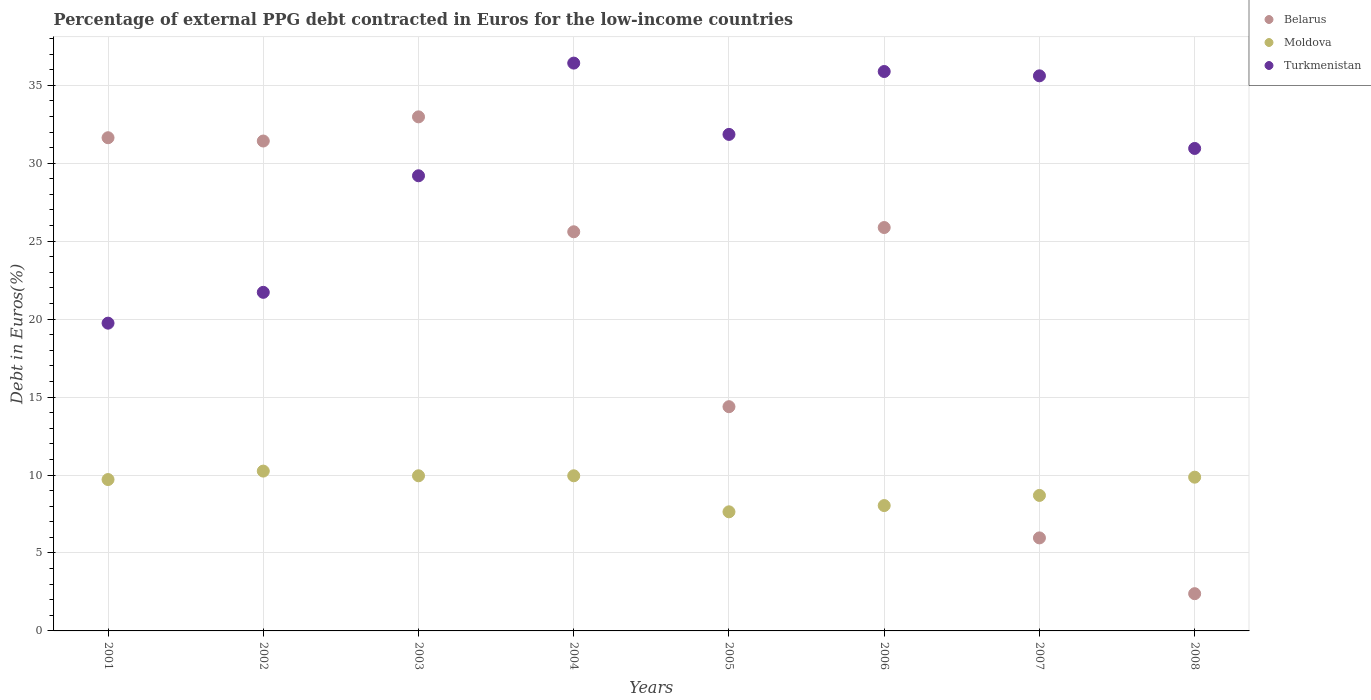Is the number of dotlines equal to the number of legend labels?
Provide a succinct answer. Yes. What is the percentage of external PPG debt contracted in Euros in Turkmenistan in 2007?
Make the answer very short. 35.6. Across all years, what is the maximum percentage of external PPG debt contracted in Euros in Moldova?
Offer a terse response. 10.25. Across all years, what is the minimum percentage of external PPG debt contracted in Euros in Belarus?
Keep it short and to the point. 2.39. In which year was the percentage of external PPG debt contracted in Euros in Turkmenistan minimum?
Keep it short and to the point. 2001. What is the total percentage of external PPG debt contracted in Euros in Moldova in the graph?
Your answer should be very brief. 74.09. What is the difference between the percentage of external PPG debt contracted in Euros in Belarus in 2006 and that in 2008?
Offer a very short reply. 23.48. What is the difference between the percentage of external PPG debt contracted in Euros in Moldova in 2006 and the percentage of external PPG debt contracted in Euros in Turkmenistan in 2003?
Your response must be concise. -21.15. What is the average percentage of external PPG debt contracted in Euros in Belarus per year?
Offer a very short reply. 21.28. In the year 2005, what is the difference between the percentage of external PPG debt contracted in Euros in Turkmenistan and percentage of external PPG debt contracted in Euros in Moldova?
Give a very brief answer. 24.21. In how many years, is the percentage of external PPG debt contracted in Euros in Moldova greater than 2 %?
Ensure brevity in your answer.  8. What is the ratio of the percentage of external PPG debt contracted in Euros in Moldova in 2003 to that in 2005?
Ensure brevity in your answer.  1.3. Is the difference between the percentage of external PPG debt contracted in Euros in Turkmenistan in 2007 and 2008 greater than the difference between the percentage of external PPG debt contracted in Euros in Moldova in 2007 and 2008?
Provide a succinct answer. Yes. What is the difference between the highest and the second highest percentage of external PPG debt contracted in Euros in Belarus?
Give a very brief answer. 1.34. What is the difference between the highest and the lowest percentage of external PPG debt contracted in Euros in Moldova?
Offer a terse response. 2.61. Is the sum of the percentage of external PPG debt contracted in Euros in Belarus in 2005 and 2007 greater than the maximum percentage of external PPG debt contracted in Euros in Moldova across all years?
Your response must be concise. Yes. Is it the case that in every year, the sum of the percentage of external PPG debt contracted in Euros in Turkmenistan and percentage of external PPG debt contracted in Euros in Belarus  is greater than the percentage of external PPG debt contracted in Euros in Moldova?
Your answer should be very brief. Yes. Does the percentage of external PPG debt contracted in Euros in Belarus monotonically increase over the years?
Keep it short and to the point. No. Is the percentage of external PPG debt contracted in Euros in Turkmenistan strictly less than the percentage of external PPG debt contracted in Euros in Moldova over the years?
Keep it short and to the point. No. How many dotlines are there?
Your response must be concise. 3. Are the values on the major ticks of Y-axis written in scientific E-notation?
Make the answer very short. No. Does the graph contain grids?
Give a very brief answer. Yes. How are the legend labels stacked?
Provide a succinct answer. Vertical. What is the title of the graph?
Give a very brief answer. Percentage of external PPG debt contracted in Euros for the low-income countries. Does "Pakistan" appear as one of the legend labels in the graph?
Ensure brevity in your answer.  No. What is the label or title of the Y-axis?
Offer a very short reply. Debt in Euros(%). What is the Debt in Euros(%) of Belarus in 2001?
Make the answer very short. 31.63. What is the Debt in Euros(%) in Moldova in 2001?
Make the answer very short. 9.71. What is the Debt in Euros(%) of Turkmenistan in 2001?
Your response must be concise. 19.74. What is the Debt in Euros(%) in Belarus in 2002?
Provide a succinct answer. 31.42. What is the Debt in Euros(%) of Moldova in 2002?
Your answer should be compact. 10.25. What is the Debt in Euros(%) in Turkmenistan in 2002?
Keep it short and to the point. 21.72. What is the Debt in Euros(%) in Belarus in 2003?
Offer a terse response. 32.97. What is the Debt in Euros(%) in Moldova in 2003?
Provide a succinct answer. 9.95. What is the Debt in Euros(%) in Turkmenistan in 2003?
Give a very brief answer. 29.19. What is the Debt in Euros(%) in Belarus in 2004?
Ensure brevity in your answer.  25.6. What is the Debt in Euros(%) in Moldova in 2004?
Your answer should be compact. 9.95. What is the Debt in Euros(%) of Turkmenistan in 2004?
Provide a succinct answer. 36.42. What is the Debt in Euros(%) in Belarus in 2005?
Give a very brief answer. 14.38. What is the Debt in Euros(%) of Moldova in 2005?
Give a very brief answer. 7.64. What is the Debt in Euros(%) in Turkmenistan in 2005?
Provide a short and direct response. 31.85. What is the Debt in Euros(%) in Belarus in 2006?
Offer a very short reply. 25.87. What is the Debt in Euros(%) of Moldova in 2006?
Give a very brief answer. 8.04. What is the Debt in Euros(%) of Turkmenistan in 2006?
Keep it short and to the point. 35.88. What is the Debt in Euros(%) in Belarus in 2007?
Provide a short and direct response. 5.97. What is the Debt in Euros(%) of Moldova in 2007?
Provide a short and direct response. 8.69. What is the Debt in Euros(%) of Turkmenistan in 2007?
Ensure brevity in your answer.  35.6. What is the Debt in Euros(%) in Belarus in 2008?
Offer a terse response. 2.39. What is the Debt in Euros(%) of Moldova in 2008?
Keep it short and to the point. 9.86. What is the Debt in Euros(%) in Turkmenistan in 2008?
Your answer should be very brief. 30.95. Across all years, what is the maximum Debt in Euros(%) in Belarus?
Keep it short and to the point. 32.97. Across all years, what is the maximum Debt in Euros(%) of Moldova?
Provide a short and direct response. 10.25. Across all years, what is the maximum Debt in Euros(%) in Turkmenistan?
Keep it short and to the point. 36.42. Across all years, what is the minimum Debt in Euros(%) of Belarus?
Provide a succinct answer. 2.39. Across all years, what is the minimum Debt in Euros(%) of Moldova?
Offer a very short reply. 7.64. Across all years, what is the minimum Debt in Euros(%) of Turkmenistan?
Keep it short and to the point. 19.74. What is the total Debt in Euros(%) in Belarus in the graph?
Offer a very short reply. 170.24. What is the total Debt in Euros(%) in Moldova in the graph?
Ensure brevity in your answer.  74.09. What is the total Debt in Euros(%) in Turkmenistan in the graph?
Keep it short and to the point. 241.35. What is the difference between the Debt in Euros(%) of Belarus in 2001 and that in 2002?
Offer a terse response. 0.21. What is the difference between the Debt in Euros(%) in Moldova in 2001 and that in 2002?
Keep it short and to the point. -0.54. What is the difference between the Debt in Euros(%) of Turkmenistan in 2001 and that in 2002?
Ensure brevity in your answer.  -1.98. What is the difference between the Debt in Euros(%) of Belarus in 2001 and that in 2003?
Provide a short and direct response. -1.34. What is the difference between the Debt in Euros(%) in Moldova in 2001 and that in 2003?
Ensure brevity in your answer.  -0.24. What is the difference between the Debt in Euros(%) of Turkmenistan in 2001 and that in 2003?
Give a very brief answer. -9.45. What is the difference between the Debt in Euros(%) of Belarus in 2001 and that in 2004?
Make the answer very short. 6.03. What is the difference between the Debt in Euros(%) in Moldova in 2001 and that in 2004?
Offer a terse response. -0.24. What is the difference between the Debt in Euros(%) of Turkmenistan in 2001 and that in 2004?
Provide a short and direct response. -16.68. What is the difference between the Debt in Euros(%) in Belarus in 2001 and that in 2005?
Ensure brevity in your answer.  17.25. What is the difference between the Debt in Euros(%) of Moldova in 2001 and that in 2005?
Your response must be concise. 2.07. What is the difference between the Debt in Euros(%) of Turkmenistan in 2001 and that in 2005?
Provide a short and direct response. -12.11. What is the difference between the Debt in Euros(%) of Belarus in 2001 and that in 2006?
Give a very brief answer. 5.76. What is the difference between the Debt in Euros(%) in Moldova in 2001 and that in 2006?
Give a very brief answer. 1.67. What is the difference between the Debt in Euros(%) of Turkmenistan in 2001 and that in 2006?
Provide a short and direct response. -16.14. What is the difference between the Debt in Euros(%) of Belarus in 2001 and that in 2007?
Offer a terse response. 25.67. What is the difference between the Debt in Euros(%) of Moldova in 2001 and that in 2007?
Your response must be concise. 1.02. What is the difference between the Debt in Euros(%) in Turkmenistan in 2001 and that in 2007?
Offer a terse response. -15.86. What is the difference between the Debt in Euros(%) in Belarus in 2001 and that in 2008?
Your answer should be very brief. 29.24. What is the difference between the Debt in Euros(%) of Moldova in 2001 and that in 2008?
Your response must be concise. -0.15. What is the difference between the Debt in Euros(%) of Turkmenistan in 2001 and that in 2008?
Ensure brevity in your answer.  -11.21. What is the difference between the Debt in Euros(%) of Belarus in 2002 and that in 2003?
Your response must be concise. -1.55. What is the difference between the Debt in Euros(%) of Moldova in 2002 and that in 2003?
Keep it short and to the point. 0.3. What is the difference between the Debt in Euros(%) of Turkmenistan in 2002 and that in 2003?
Offer a very short reply. -7.48. What is the difference between the Debt in Euros(%) in Belarus in 2002 and that in 2004?
Your answer should be compact. 5.82. What is the difference between the Debt in Euros(%) in Moldova in 2002 and that in 2004?
Your answer should be very brief. 0.3. What is the difference between the Debt in Euros(%) of Turkmenistan in 2002 and that in 2004?
Your answer should be compact. -14.7. What is the difference between the Debt in Euros(%) of Belarus in 2002 and that in 2005?
Offer a terse response. 17.04. What is the difference between the Debt in Euros(%) of Moldova in 2002 and that in 2005?
Provide a short and direct response. 2.61. What is the difference between the Debt in Euros(%) in Turkmenistan in 2002 and that in 2005?
Ensure brevity in your answer.  -10.13. What is the difference between the Debt in Euros(%) of Belarus in 2002 and that in 2006?
Offer a very short reply. 5.55. What is the difference between the Debt in Euros(%) of Moldova in 2002 and that in 2006?
Keep it short and to the point. 2.21. What is the difference between the Debt in Euros(%) of Turkmenistan in 2002 and that in 2006?
Provide a short and direct response. -14.16. What is the difference between the Debt in Euros(%) in Belarus in 2002 and that in 2007?
Keep it short and to the point. 25.46. What is the difference between the Debt in Euros(%) of Moldova in 2002 and that in 2007?
Keep it short and to the point. 1.56. What is the difference between the Debt in Euros(%) of Turkmenistan in 2002 and that in 2007?
Give a very brief answer. -13.89. What is the difference between the Debt in Euros(%) in Belarus in 2002 and that in 2008?
Your response must be concise. 29.03. What is the difference between the Debt in Euros(%) in Moldova in 2002 and that in 2008?
Your answer should be very brief. 0.39. What is the difference between the Debt in Euros(%) in Turkmenistan in 2002 and that in 2008?
Offer a terse response. -9.23. What is the difference between the Debt in Euros(%) of Belarus in 2003 and that in 2004?
Provide a succinct answer. 7.37. What is the difference between the Debt in Euros(%) of Moldova in 2003 and that in 2004?
Give a very brief answer. 0. What is the difference between the Debt in Euros(%) of Turkmenistan in 2003 and that in 2004?
Provide a short and direct response. -7.23. What is the difference between the Debt in Euros(%) of Belarus in 2003 and that in 2005?
Offer a terse response. 18.59. What is the difference between the Debt in Euros(%) in Moldova in 2003 and that in 2005?
Your answer should be very brief. 2.31. What is the difference between the Debt in Euros(%) of Turkmenistan in 2003 and that in 2005?
Keep it short and to the point. -2.65. What is the difference between the Debt in Euros(%) of Belarus in 2003 and that in 2006?
Offer a terse response. 7.1. What is the difference between the Debt in Euros(%) of Moldova in 2003 and that in 2006?
Give a very brief answer. 1.91. What is the difference between the Debt in Euros(%) in Turkmenistan in 2003 and that in 2006?
Give a very brief answer. -6.69. What is the difference between the Debt in Euros(%) of Belarus in 2003 and that in 2007?
Offer a very short reply. 27.01. What is the difference between the Debt in Euros(%) of Moldova in 2003 and that in 2007?
Give a very brief answer. 1.26. What is the difference between the Debt in Euros(%) in Turkmenistan in 2003 and that in 2007?
Make the answer very short. -6.41. What is the difference between the Debt in Euros(%) in Belarus in 2003 and that in 2008?
Offer a terse response. 30.58. What is the difference between the Debt in Euros(%) in Moldova in 2003 and that in 2008?
Make the answer very short. 0.09. What is the difference between the Debt in Euros(%) of Turkmenistan in 2003 and that in 2008?
Your answer should be compact. -1.75. What is the difference between the Debt in Euros(%) in Belarus in 2004 and that in 2005?
Give a very brief answer. 11.22. What is the difference between the Debt in Euros(%) of Moldova in 2004 and that in 2005?
Make the answer very short. 2.31. What is the difference between the Debt in Euros(%) in Turkmenistan in 2004 and that in 2005?
Your answer should be very brief. 4.57. What is the difference between the Debt in Euros(%) in Belarus in 2004 and that in 2006?
Keep it short and to the point. -0.27. What is the difference between the Debt in Euros(%) of Moldova in 2004 and that in 2006?
Give a very brief answer. 1.91. What is the difference between the Debt in Euros(%) of Turkmenistan in 2004 and that in 2006?
Make the answer very short. 0.54. What is the difference between the Debt in Euros(%) of Belarus in 2004 and that in 2007?
Your answer should be very brief. 19.64. What is the difference between the Debt in Euros(%) in Moldova in 2004 and that in 2007?
Keep it short and to the point. 1.26. What is the difference between the Debt in Euros(%) of Turkmenistan in 2004 and that in 2007?
Offer a very short reply. 0.82. What is the difference between the Debt in Euros(%) of Belarus in 2004 and that in 2008?
Keep it short and to the point. 23.21. What is the difference between the Debt in Euros(%) of Moldova in 2004 and that in 2008?
Keep it short and to the point. 0.09. What is the difference between the Debt in Euros(%) of Turkmenistan in 2004 and that in 2008?
Ensure brevity in your answer.  5.47. What is the difference between the Debt in Euros(%) of Belarus in 2005 and that in 2006?
Give a very brief answer. -11.49. What is the difference between the Debt in Euros(%) of Moldova in 2005 and that in 2006?
Your response must be concise. -0.4. What is the difference between the Debt in Euros(%) of Turkmenistan in 2005 and that in 2006?
Your answer should be compact. -4.03. What is the difference between the Debt in Euros(%) in Belarus in 2005 and that in 2007?
Ensure brevity in your answer.  8.42. What is the difference between the Debt in Euros(%) of Moldova in 2005 and that in 2007?
Make the answer very short. -1.05. What is the difference between the Debt in Euros(%) in Turkmenistan in 2005 and that in 2007?
Give a very brief answer. -3.76. What is the difference between the Debt in Euros(%) in Belarus in 2005 and that in 2008?
Offer a very short reply. 11.99. What is the difference between the Debt in Euros(%) in Moldova in 2005 and that in 2008?
Your answer should be compact. -2.22. What is the difference between the Debt in Euros(%) of Turkmenistan in 2005 and that in 2008?
Ensure brevity in your answer.  0.9. What is the difference between the Debt in Euros(%) in Belarus in 2006 and that in 2007?
Offer a very short reply. 19.91. What is the difference between the Debt in Euros(%) of Moldova in 2006 and that in 2007?
Your response must be concise. -0.65. What is the difference between the Debt in Euros(%) in Turkmenistan in 2006 and that in 2007?
Provide a short and direct response. 0.28. What is the difference between the Debt in Euros(%) of Belarus in 2006 and that in 2008?
Ensure brevity in your answer.  23.48. What is the difference between the Debt in Euros(%) of Moldova in 2006 and that in 2008?
Your answer should be very brief. -1.82. What is the difference between the Debt in Euros(%) of Turkmenistan in 2006 and that in 2008?
Offer a very short reply. 4.94. What is the difference between the Debt in Euros(%) in Belarus in 2007 and that in 2008?
Your answer should be very brief. 3.58. What is the difference between the Debt in Euros(%) of Moldova in 2007 and that in 2008?
Provide a short and direct response. -1.17. What is the difference between the Debt in Euros(%) in Turkmenistan in 2007 and that in 2008?
Make the answer very short. 4.66. What is the difference between the Debt in Euros(%) of Belarus in 2001 and the Debt in Euros(%) of Moldova in 2002?
Your answer should be compact. 21.38. What is the difference between the Debt in Euros(%) in Belarus in 2001 and the Debt in Euros(%) in Turkmenistan in 2002?
Offer a very short reply. 9.92. What is the difference between the Debt in Euros(%) of Moldova in 2001 and the Debt in Euros(%) of Turkmenistan in 2002?
Offer a very short reply. -12.01. What is the difference between the Debt in Euros(%) of Belarus in 2001 and the Debt in Euros(%) of Moldova in 2003?
Ensure brevity in your answer.  21.68. What is the difference between the Debt in Euros(%) of Belarus in 2001 and the Debt in Euros(%) of Turkmenistan in 2003?
Offer a very short reply. 2.44. What is the difference between the Debt in Euros(%) in Moldova in 2001 and the Debt in Euros(%) in Turkmenistan in 2003?
Make the answer very short. -19.48. What is the difference between the Debt in Euros(%) in Belarus in 2001 and the Debt in Euros(%) in Moldova in 2004?
Ensure brevity in your answer.  21.68. What is the difference between the Debt in Euros(%) of Belarus in 2001 and the Debt in Euros(%) of Turkmenistan in 2004?
Offer a terse response. -4.79. What is the difference between the Debt in Euros(%) in Moldova in 2001 and the Debt in Euros(%) in Turkmenistan in 2004?
Offer a terse response. -26.71. What is the difference between the Debt in Euros(%) of Belarus in 2001 and the Debt in Euros(%) of Moldova in 2005?
Make the answer very short. 23.99. What is the difference between the Debt in Euros(%) in Belarus in 2001 and the Debt in Euros(%) in Turkmenistan in 2005?
Your answer should be compact. -0.21. What is the difference between the Debt in Euros(%) in Moldova in 2001 and the Debt in Euros(%) in Turkmenistan in 2005?
Give a very brief answer. -22.14. What is the difference between the Debt in Euros(%) of Belarus in 2001 and the Debt in Euros(%) of Moldova in 2006?
Ensure brevity in your answer.  23.59. What is the difference between the Debt in Euros(%) in Belarus in 2001 and the Debt in Euros(%) in Turkmenistan in 2006?
Provide a short and direct response. -4.25. What is the difference between the Debt in Euros(%) of Moldova in 2001 and the Debt in Euros(%) of Turkmenistan in 2006?
Offer a very short reply. -26.17. What is the difference between the Debt in Euros(%) of Belarus in 2001 and the Debt in Euros(%) of Moldova in 2007?
Make the answer very short. 22.94. What is the difference between the Debt in Euros(%) of Belarus in 2001 and the Debt in Euros(%) of Turkmenistan in 2007?
Offer a terse response. -3.97. What is the difference between the Debt in Euros(%) of Moldova in 2001 and the Debt in Euros(%) of Turkmenistan in 2007?
Provide a short and direct response. -25.89. What is the difference between the Debt in Euros(%) of Belarus in 2001 and the Debt in Euros(%) of Moldova in 2008?
Offer a very short reply. 21.77. What is the difference between the Debt in Euros(%) in Belarus in 2001 and the Debt in Euros(%) in Turkmenistan in 2008?
Your response must be concise. 0.69. What is the difference between the Debt in Euros(%) of Moldova in 2001 and the Debt in Euros(%) of Turkmenistan in 2008?
Ensure brevity in your answer.  -21.24. What is the difference between the Debt in Euros(%) in Belarus in 2002 and the Debt in Euros(%) in Moldova in 2003?
Keep it short and to the point. 21.47. What is the difference between the Debt in Euros(%) in Belarus in 2002 and the Debt in Euros(%) in Turkmenistan in 2003?
Provide a short and direct response. 2.23. What is the difference between the Debt in Euros(%) of Moldova in 2002 and the Debt in Euros(%) of Turkmenistan in 2003?
Provide a short and direct response. -18.94. What is the difference between the Debt in Euros(%) of Belarus in 2002 and the Debt in Euros(%) of Moldova in 2004?
Give a very brief answer. 21.47. What is the difference between the Debt in Euros(%) in Belarus in 2002 and the Debt in Euros(%) in Turkmenistan in 2004?
Make the answer very short. -5. What is the difference between the Debt in Euros(%) of Moldova in 2002 and the Debt in Euros(%) of Turkmenistan in 2004?
Offer a terse response. -26.17. What is the difference between the Debt in Euros(%) in Belarus in 2002 and the Debt in Euros(%) in Moldova in 2005?
Keep it short and to the point. 23.78. What is the difference between the Debt in Euros(%) in Belarus in 2002 and the Debt in Euros(%) in Turkmenistan in 2005?
Your answer should be compact. -0.42. What is the difference between the Debt in Euros(%) of Moldova in 2002 and the Debt in Euros(%) of Turkmenistan in 2005?
Provide a succinct answer. -21.6. What is the difference between the Debt in Euros(%) in Belarus in 2002 and the Debt in Euros(%) in Moldova in 2006?
Give a very brief answer. 23.38. What is the difference between the Debt in Euros(%) of Belarus in 2002 and the Debt in Euros(%) of Turkmenistan in 2006?
Offer a very short reply. -4.46. What is the difference between the Debt in Euros(%) of Moldova in 2002 and the Debt in Euros(%) of Turkmenistan in 2006?
Make the answer very short. -25.63. What is the difference between the Debt in Euros(%) of Belarus in 2002 and the Debt in Euros(%) of Moldova in 2007?
Provide a succinct answer. 22.73. What is the difference between the Debt in Euros(%) in Belarus in 2002 and the Debt in Euros(%) in Turkmenistan in 2007?
Make the answer very short. -4.18. What is the difference between the Debt in Euros(%) in Moldova in 2002 and the Debt in Euros(%) in Turkmenistan in 2007?
Offer a very short reply. -25.35. What is the difference between the Debt in Euros(%) in Belarus in 2002 and the Debt in Euros(%) in Moldova in 2008?
Your response must be concise. 21.56. What is the difference between the Debt in Euros(%) of Belarus in 2002 and the Debt in Euros(%) of Turkmenistan in 2008?
Offer a very short reply. 0.48. What is the difference between the Debt in Euros(%) of Moldova in 2002 and the Debt in Euros(%) of Turkmenistan in 2008?
Your answer should be very brief. -20.69. What is the difference between the Debt in Euros(%) of Belarus in 2003 and the Debt in Euros(%) of Moldova in 2004?
Provide a succinct answer. 23.02. What is the difference between the Debt in Euros(%) of Belarus in 2003 and the Debt in Euros(%) of Turkmenistan in 2004?
Offer a terse response. -3.45. What is the difference between the Debt in Euros(%) of Moldova in 2003 and the Debt in Euros(%) of Turkmenistan in 2004?
Your answer should be compact. -26.47. What is the difference between the Debt in Euros(%) in Belarus in 2003 and the Debt in Euros(%) in Moldova in 2005?
Your response must be concise. 25.33. What is the difference between the Debt in Euros(%) of Belarus in 2003 and the Debt in Euros(%) of Turkmenistan in 2005?
Keep it short and to the point. 1.13. What is the difference between the Debt in Euros(%) in Moldova in 2003 and the Debt in Euros(%) in Turkmenistan in 2005?
Your answer should be very brief. -21.9. What is the difference between the Debt in Euros(%) of Belarus in 2003 and the Debt in Euros(%) of Moldova in 2006?
Provide a short and direct response. 24.93. What is the difference between the Debt in Euros(%) of Belarus in 2003 and the Debt in Euros(%) of Turkmenistan in 2006?
Your answer should be very brief. -2.91. What is the difference between the Debt in Euros(%) in Moldova in 2003 and the Debt in Euros(%) in Turkmenistan in 2006?
Ensure brevity in your answer.  -25.93. What is the difference between the Debt in Euros(%) of Belarus in 2003 and the Debt in Euros(%) of Moldova in 2007?
Provide a short and direct response. 24.28. What is the difference between the Debt in Euros(%) in Belarus in 2003 and the Debt in Euros(%) in Turkmenistan in 2007?
Ensure brevity in your answer.  -2.63. What is the difference between the Debt in Euros(%) of Moldova in 2003 and the Debt in Euros(%) of Turkmenistan in 2007?
Your answer should be compact. -25.65. What is the difference between the Debt in Euros(%) in Belarus in 2003 and the Debt in Euros(%) in Moldova in 2008?
Ensure brevity in your answer.  23.11. What is the difference between the Debt in Euros(%) of Belarus in 2003 and the Debt in Euros(%) of Turkmenistan in 2008?
Your response must be concise. 2.03. What is the difference between the Debt in Euros(%) of Moldova in 2003 and the Debt in Euros(%) of Turkmenistan in 2008?
Make the answer very short. -20.99. What is the difference between the Debt in Euros(%) of Belarus in 2004 and the Debt in Euros(%) of Moldova in 2005?
Your answer should be compact. 17.96. What is the difference between the Debt in Euros(%) of Belarus in 2004 and the Debt in Euros(%) of Turkmenistan in 2005?
Your response must be concise. -6.25. What is the difference between the Debt in Euros(%) in Moldova in 2004 and the Debt in Euros(%) in Turkmenistan in 2005?
Your answer should be very brief. -21.9. What is the difference between the Debt in Euros(%) in Belarus in 2004 and the Debt in Euros(%) in Moldova in 2006?
Your answer should be compact. 17.56. What is the difference between the Debt in Euros(%) of Belarus in 2004 and the Debt in Euros(%) of Turkmenistan in 2006?
Keep it short and to the point. -10.28. What is the difference between the Debt in Euros(%) of Moldova in 2004 and the Debt in Euros(%) of Turkmenistan in 2006?
Keep it short and to the point. -25.93. What is the difference between the Debt in Euros(%) in Belarus in 2004 and the Debt in Euros(%) in Moldova in 2007?
Offer a very short reply. 16.91. What is the difference between the Debt in Euros(%) in Belarus in 2004 and the Debt in Euros(%) in Turkmenistan in 2007?
Provide a short and direct response. -10. What is the difference between the Debt in Euros(%) of Moldova in 2004 and the Debt in Euros(%) of Turkmenistan in 2007?
Ensure brevity in your answer.  -25.65. What is the difference between the Debt in Euros(%) of Belarus in 2004 and the Debt in Euros(%) of Moldova in 2008?
Your answer should be very brief. 15.74. What is the difference between the Debt in Euros(%) of Belarus in 2004 and the Debt in Euros(%) of Turkmenistan in 2008?
Offer a terse response. -5.34. What is the difference between the Debt in Euros(%) in Moldova in 2004 and the Debt in Euros(%) in Turkmenistan in 2008?
Make the answer very short. -20.99. What is the difference between the Debt in Euros(%) of Belarus in 2005 and the Debt in Euros(%) of Moldova in 2006?
Your answer should be compact. 6.34. What is the difference between the Debt in Euros(%) in Belarus in 2005 and the Debt in Euros(%) in Turkmenistan in 2006?
Provide a succinct answer. -21.5. What is the difference between the Debt in Euros(%) of Moldova in 2005 and the Debt in Euros(%) of Turkmenistan in 2006?
Your response must be concise. -28.24. What is the difference between the Debt in Euros(%) of Belarus in 2005 and the Debt in Euros(%) of Moldova in 2007?
Give a very brief answer. 5.69. What is the difference between the Debt in Euros(%) of Belarus in 2005 and the Debt in Euros(%) of Turkmenistan in 2007?
Provide a short and direct response. -21.22. What is the difference between the Debt in Euros(%) of Moldova in 2005 and the Debt in Euros(%) of Turkmenistan in 2007?
Offer a very short reply. -27.96. What is the difference between the Debt in Euros(%) of Belarus in 2005 and the Debt in Euros(%) of Moldova in 2008?
Your answer should be very brief. 4.52. What is the difference between the Debt in Euros(%) of Belarus in 2005 and the Debt in Euros(%) of Turkmenistan in 2008?
Give a very brief answer. -16.56. What is the difference between the Debt in Euros(%) of Moldova in 2005 and the Debt in Euros(%) of Turkmenistan in 2008?
Keep it short and to the point. -23.31. What is the difference between the Debt in Euros(%) of Belarus in 2006 and the Debt in Euros(%) of Moldova in 2007?
Ensure brevity in your answer.  17.18. What is the difference between the Debt in Euros(%) of Belarus in 2006 and the Debt in Euros(%) of Turkmenistan in 2007?
Offer a very short reply. -9.73. What is the difference between the Debt in Euros(%) in Moldova in 2006 and the Debt in Euros(%) in Turkmenistan in 2007?
Offer a very short reply. -27.56. What is the difference between the Debt in Euros(%) of Belarus in 2006 and the Debt in Euros(%) of Moldova in 2008?
Keep it short and to the point. 16.01. What is the difference between the Debt in Euros(%) of Belarus in 2006 and the Debt in Euros(%) of Turkmenistan in 2008?
Offer a terse response. -5.07. What is the difference between the Debt in Euros(%) in Moldova in 2006 and the Debt in Euros(%) in Turkmenistan in 2008?
Your answer should be compact. -22.91. What is the difference between the Debt in Euros(%) in Belarus in 2007 and the Debt in Euros(%) in Moldova in 2008?
Your response must be concise. -3.9. What is the difference between the Debt in Euros(%) of Belarus in 2007 and the Debt in Euros(%) of Turkmenistan in 2008?
Provide a succinct answer. -24.98. What is the difference between the Debt in Euros(%) of Moldova in 2007 and the Debt in Euros(%) of Turkmenistan in 2008?
Keep it short and to the point. -22.25. What is the average Debt in Euros(%) of Belarus per year?
Make the answer very short. 21.28. What is the average Debt in Euros(%) of Moldova per year?
Offer a very short reply. 9.26. What is the average Debt in Euros(%) of Turkmenistan per year?
Provide a succinct answer. 30.17. In the year 2001, what is the difference between the Debt in Euros(%) of Belarus and Debt in Euros(%) of Moldova?
Offer a terse response. 21.92. In the year 2001, what is the difference between the Debt in Euros(%) of Belarus and Debt in Euros(%) of Turkmenistan?
Keep it short and to the point. 11.89. In the year 2001, what is the difference between the Debt in Euros(%) in Moldova and Debt in Euros(%) in Turkmenistan?
Provide a short and direct response. -10.03. In the year 2002, what is the difference between the Debt in Euros(%) of Belarus and Debt in Euros(%) of Moldova?
Your answer should be compact. 21.17. In the year 2002, what is the difference between the Debt in Euros(%) of Belarus and Debt in Euros(%) of Turkmenistan?
Offer a very short reply. 9.71. In the year 2002, what is the difference between the Debt in Euros(%) in Moldova and Debt in Euros(%) in Turkmenistan?
Your response must be concise. -11.47. In the year 2003, what is the difference between the Debt in Euros(%) in Belarus and Debt in Euros(%) in Moldova?
Provide a succinct answer. 23.02. In the year 2003, what is the difference between the Debt in Euros(%) of Belarus and Debt in Euros(%) of Turkmenistan?
Offer a terse response. 3.78. In the year 2003, what is the difference between the Debt in Euros(%) of Moldova and Debt in Euros(%) of Turkmenistan?
Provide a succinct answer. -19.24. In the year 2004, what is the difference between the Debt in Euros(%) of Belarus and Debt in Euros(%) of Moldova?
Give a very brief answer. 15.65. In the year 2004, what is the difference between the Debt in Euros(%) of Belarus and Debt in Euros(%) of Turkmenistan?
Provide a succinct answer. -10.82. In the year 2004, what is the difference between the Debt in Euros(%) of Moldova and Debt in Euros(%) of Turkmenistan?
Ensure brevity in your answer.  -26.47. In the year 2005, what is the difference between the Debt in Euros(%) of Belarus and Debt in Euros(%) of Moldova?
Offer a terse response. 6.74. In the year 2005, what is the difference between the Debt in Euros(%) of Belarus and Debt in Euros(%) of Turkmenistan?
Your answer should be very brief. -17.46. In the year 2005, what is the difference between the Debt in Euros(%) in Moldova and Debt in Euros(%) in Turkmenistan?
Ensure brevity in your answer.  -24.21. In the year 2006, what is the difference between the Debt in Euros(%) of Belarus and Debt in Euros(%) of Moldova?
Give a very brief answer. 17.83. In the year 2006, what is the difference between the Debt in Euros(%) of Belarus and Debt in Euros(%) of Turkmenistan?
Offer a terse response. -10.01. In the year 2006, what is the difference between the Debt in Euros(%) in Moldova and Debt in Euros(%) in Turkmenistan?
Make the answer very short. -27.84. In the year 2007, what is the difference between the Debt in Euros(%) in Belarus and Debt in Euros(%) in Moldova?
Provide a succinct answer. -2.72. In the year 2007, what is the difference between the Debt in Euros(%) in Belarus and Debt in Euros(%) in Turkmenistan?
Your response must be concise. -29.64. In the year 2007, what is the difference between the Debt in Euros(%) in Moldova and Debt in Euros(%) in Turkmenistan?
Your answer should be very brief. -26.91. In the year 2008, what is the difference between the Debt in Euros(%) of Belarus and Debt in Euros(%) of Moldova?
Your answer should be compact. -7.47. In the year 2008, what is the difference between the Debt in Euros(%) in Belarus and Debt in Euros(%) in Turkmenistan?
Make the answer very short. -28.56. In the year 2008, what is the difference between the Debt in Euros(%) of Moldova and Debt in Euros(%) of Turkmenistan?
Provide a short and direct response. -21.08. What is the ratio of the Debt in Euros(%) of Belarus in 2001 to that in 2002?
Provide a short and direct response. 1.01. What is the ratio of the Debt in Euros(%) of Moldova in 2001 to that in 2002?
Ensure brevity in your answer.  0.95. What is the ratio of the Debt in Euros(%) of Turkmenistan in 2001 to that in 2002?
Provide a succinct answer. 0.91. What is the ratio of the Debt in Euros(%) of Belarus in 2001 to that in 2003?
Provide a short and direct response. 0.96. What is the ratio of the Debt in Euros(%) in Moldova in 2001 to that in 2003?
Offer a terse response. 0.98. What is the ratio of the Debt in Euros(%) in Turkmenistan in 2001 to that in 2003?
Keep it short and to the point. 0.68. What is the ratio of the Debt in Euros(%) of Belarus in 2001 to that in 2004?
Make the answer very short. 1.24. What is the ratio of the Debt in Euros(%) in Moldova in 2001 to that in 2004?
Ensure brevity in your answer.  0.98. What is the ratio of the Debt in Euros(%) in Turkmenistan in 2001 to that in 2004?
Offer a very short reply. 0.54. What is the ratio of the Debt in Euros(%) in Belarus in 2001 to that in 2005?
Offer a very short reply. 2.2. What is the ratio of the Debt in Euros(%) of Moldova in 2001 to that in 2005?
Offer a very short reply. 1.27. What is the ratio of the Debt in Euros(%) in Turkmenistan in 2001 to that in 2005?
Give a very brief answer. 0.62. What is the ratio of the Debt in Euros(%) of Belarus in 2001 to that in 2006?
Make the answer very short. 1.22. What is the ratio of the Debt in Euros(%) of Moldova in 2001 to that in 2006?
Your response must be concise. 1.21. What is the ratio of the Debt in Euros(%) of Turkmenistan in 2001 to that in 2006?
Keep it short and to the point. 0.55. What is the ratio of the Debt in Euros(%) of Belarus in 2001 to that in 2007?
Your answer should be very brief. 5.3. What is the ratio of the Debt in Euros(%) of Moldova in 2001 to that in 2007?
Your response must be concise. 1.12. What is the ratio of the Debt in Euros(%) of Turkmenistan in 2001 to that in 2007?
Offer a terse response. 0.55. What is the ratio of the Debt in Euros(%) in Belarus in 2001 to that in 2008?
Offer a terse response. 13.24. What is the ratio of the Debt in Euros(%) in Moldova in 2001 to that in 2008?
Keep it short and to the point. 0.98. What is the ratio of the Debt in Euros(%) of Turkmenistan in 2001 to that in 2008?
Your response must be concise. 0.64. What is the ratio of the Debt in Euros(%) in Belarus in 2002 to that in 2003?
Your answer should be compact. 0.95. What is the ratio of the Debt in Euros(%) of Moldova in 2002 to that in 2003?
Give a very brief answer. 1.03. What is the ratio of the Debt in Euros(%) of Turkmenistan in 2002 to that in 2003?
Give a very brief answer. 0.74. What is the ratio of the Debt in Euros(%) in Belarus in 2002 to that in 2004?
Your response must be concise. 1.23. What is the ratio of the Debt in Euros(%) of Moldova in 2002 to that in 2004?
Offer a terse response. 1.03. What is the ratio of the Debt in Euros(%) in Turkmenistan in 2002 to that in 2004?
Make the answer very short. 0.6. What is the ratio of the Debt in Euros(%) in Belarus in 2002 to that in 2005?
Your answer should be very brief. 2.18. What is the ratio of the Debt in Euros(%) in Moldova in 2002 to that in 2005?
Give a very brief answer. 1.34. What is the ratio of the Debt in Euros(%) in Turkmenistan in 2002 to that in 2005?
Your answer should be compact. 0.68. What is the ratio of the Debt in Euros(%) in Belarus in 2002 to that in 2006?
Keep it short and to the point. 1.21. What is the ratio of the Debt in Euros(%) of Moldova in 2002 to that in 2006?
Keep it short and to the point. 1.27. What is the ratio of the Debt in Euros(%) in Turkmenistan in 2002 to that in 2006?
Offer a terse response. 0.61. What is the ratio of the Debt in Euros(%) in Belarus in 2002 to that in 2007?
Make the answer very short. 5.27. What is the ratio of the Debt in Euros(%) in Moldova in 2002 to that in 2007?
Keep it short and to the point. 1.18. What is the ratio of the Debt in Euros(%) in Turkmenistan in 2002 to that in 2007?
Ensure brevity in your answer.  0.61. What is the ratio of the Debt in Euros(%) in Belarus in 2002 to that in 2008?
Your answer should be very brief. 13.16. What is the ratio of the Debt in Euros(%) in Moldova in 2002 to that in 2008?
Offer a very short reply. 1.04. What is the ratio of the Debt in Euros(%) in Turkmenistan in 2002 to that in 2008?
Give a very brief answer. 0.7. What is the ratio of the Debt in Euros(%) in Belarus in 2003 to that in 2004?
Provide a short and direct response. 1.29. What is the ratio of the Debt in Euros(%) of Moldova in 2003 to that in 2004?
Offer a very short reply. 1. What is the ratio of the Debt in Euros(%) of Turkmenistan in 2003 to that in 2004?
Ensure brevity in your answer.  0.8. What is the ratio of the Debt in Euros(%) in Belarus in 2003 to that in 2005?
Your response must be concise. 2.29. What is the ratio of the Debt in Euros(%) in Moldova in 2003 to that in 2005?
Keep it short and to the point. 1.3. What is the ratio of the Debt in Euros(%) of Turkmenistan in 2003 to that in 2005?
Provide a succinct answer. 0.92. What is the ratio of the Debt in Euros(%) of Belarus in 2003 to that in 2006?
Keep it short and to the point. 1.27. What is the ratio of the Debt in Euros(%) in Moldova in 2003 to that in 2006?
Your answer should be compact. 1.24. What is the ratio of the Debt in Euros(%) of Turkmenistan in 2003 to that in 2006?
Offer a terse response. 0.81. What is the ratio of the Debt in Euros(%) of Belarus in 2003 to that in 2007?
Give a very brief answer. 5.53. What is the ratio of the Debt in Euros(%) in Moldova in 2003 to that in 2007?
Your answer should be very brief. 1.14. What is the ratio of the Debt in Euros(%) of Turkmenistan in 2003 to that in 2007?
Provide a short and direct response. 0.82. What is the ratio of the Debt in Euros(%) in Belarus in 2003 to that in 2008?
Make the answer very short. 13.8. What is the ratio of the Debt in Euros(%) in Turkmenistan in 2003 to that in 2008?
Offer a very short reply. 0.94. What is the ratio of the Debt in Euros(%) of Belarus in 2004 to that in 2005?
Provide a short and direct response. 1.78. What is the ratio of the Debt in Euros(%) of Moldova in 2004 to that in 2005?
Offer a terse response. 1.3. What is the ratio of the Debt in Euros(%) in Turkmenistan in 2004 to that in 2005?
Make the answer very short. 1.14. What is the ratio of the Debt in Euros(%) in Belarus in 2004 to that in 2006?
Your response must be concise. 0.99. What is the ratio of the Debt in Euros(%) of Moldova in 2004 to that in 2006?
Offer a very short reply. 1.24. What is the ratio of the Debt in Euros(%) in Turkmenistan in 2004 to that in 2006?
Make the answer very short. 1.01. What is the ratio of the Debt in Euros(%) of Belarus in 2004 to that in 2007?
Keep it short and to the point. 4.29. What is the ratio of the Debt in Euros(%) of Moldova in 2004 to that in 2007?
Make the answer very short. 1.14. What is the ratio of the Debt in Euros(%) of Turkmenistan in 2004 to that in 2007?
Offer a very short reply. 1.02. What is the ratio of the Debt in Euros(%) in Belarus in 2004 to that in 2008?
Give a very brief answer. 10.72. What is the ratio of the Debt in Euros(%) in Turkmenistan in 2004 to that in 2008?
Make the answer very short. 1.18. What is the ratio of the Debt in Euros(%) in Belarus in 2005 to that in 2006?
Your response must be concise. 0.56. What is the ratio of the Debt in Euros(%) in Moldova in 2005 to that in 2006?
Your answer should be very brief. 0.95. What is the ratio of the Debt in Euros(%) in Turkmenistan in 2005 to that in 2006?
Give a very brief answer. 0.89. What is the ratio of the Debt in Euros(%) of Belarus in 2005 to that in 2007?
Give a very brief answer. 2.41. What is the ratio of the Debt in Euros(%) of Moldova in 2005 to that in 2007?
Provide a succinct answer. 0.88. What is the ratio of the Debt in Euros(%) of Turkmenistan in 2005 to that in 2007?
Keep it short and to the point. 0.89. What is the ratio of the Debt in Euros(%) of Belarus in 2005 to that in 2008?
Your answer should be compact. 6.02. What is the ratio of the Debt in Euros(%) in Moldova in 2005 to that in 2008?
Your answer should be compact. 0.77. What is the ratio of the Debt in Euros(%) in Turkmenistan in 2005 to that in 2008?
Give a very brief answer. 1.03. What is the ratio of the Debt in Euros(%) in Belarus in 2006 to that in 2007?
Provide a short and direct response. 4.34. What is the ratio of the Debt in Euros(%) in Moldova in 2006 to that in 2007?
Your answer should be compact. 0.93. What is the ratio of the Debt in Euros(%) in Turkmenistan in 2006 to that in 2007?
Ensure brevity in your answer.  1.01. What is the ratio of the Debt in Euros(%) in Belarus in 2006 to that in 2008?
Your answer should be very brief. 10.83. What is the ratio of the Debt in Euros(%) of Moldova in 2006 to that in 2008?
Provide a short and direct response. 0.82. What is the ratio of the Debt in Euros(%) of Turkmenistan in 2006 to that in 2008?
Your answer should be very brief. 1.16. What is the ratio of the Debt in Euros(%) in Belarus in 2007 to that in 2008?
Give a very brief answer. 2.5. What is the ratio of the Debt in Euros(%) of Moldova in 2007 to that in 2008?
Your response must be concise. 0.88. What is the ratio of the Debt in Euros(%) in Turkmenistan in 2007 to that in 2008?
Provide a succinct answer. 1.15. What is the difference between the highest and the second highest Debt in Euros(%) in Belarus?
Offer a terse response. 1.34. What is the difference between the highest and the second highest Debt in Euros(%) of Moldova?
Give a very brief answer. 0.3. What is the difference between the highest and the second highest Debt in Euros(%) in Turkmenistan?
Offer a very short reply. 0.54. What is the difference between the highest and the lowest Debt in Euros(%) of Belarus?
Make the answer very short. 30.58. What is the difference between the highest and the lowest Debt in Euros(%) of Moldova?
Offer a terse response. 2.61. What is the difference between the highest and the lowest Debt in Euros(%) of Turkmenistan?
Your response must be concise. 16.68. 